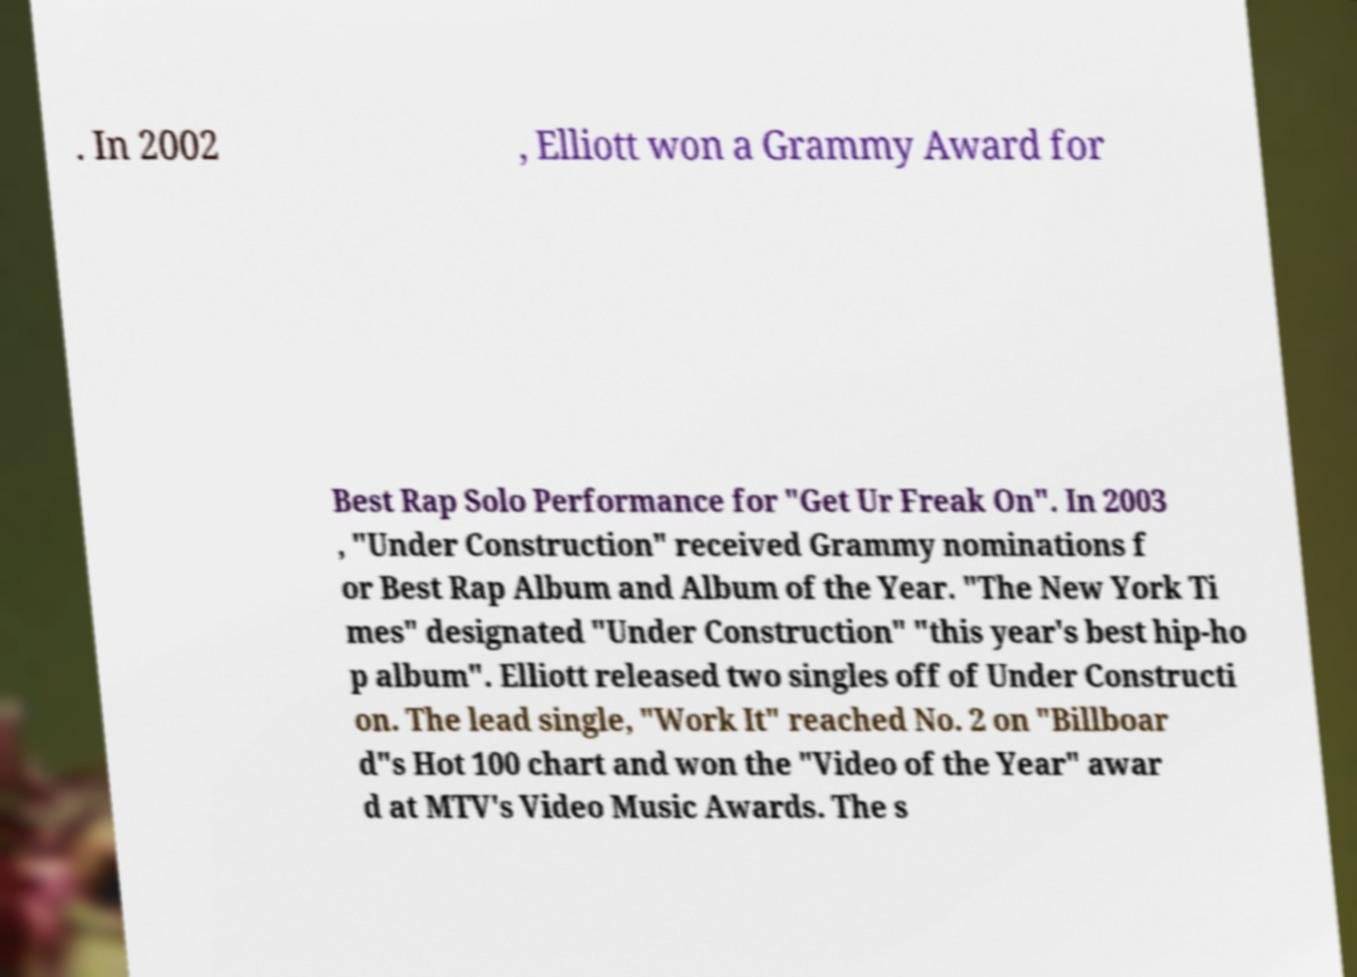Could you assist in decoding the text presented in this image and type it out clearly? . In 2002 , Elliott won a Grammy Award for Best Rap Solo Performance for "Get Ur Freak On". In 2003 , "Under Construction" received Grammy nominations f or Best Rap Album and Album of the Year. "The New York Ti mes" designated "Under Construction" "this year's best hip-ho p album". Elliott released two singles off of Under Constructi on. The lead single, "Work It" reached No. 2 on "Billboar d"s Hot 100 chart and won the "Video of the Year" awar d at MTV's Video Music Awards. The s 